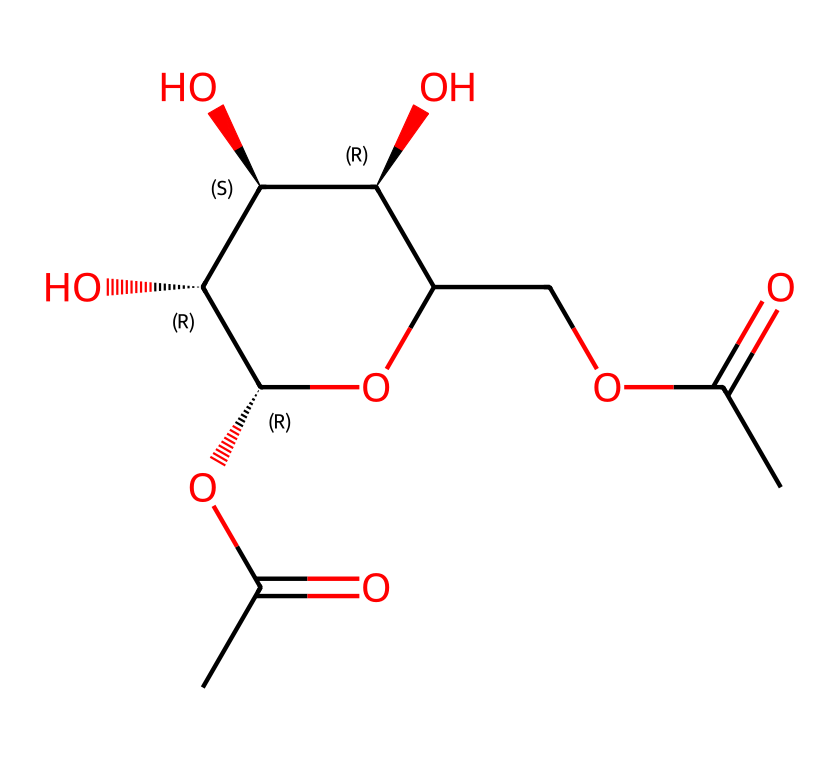What type of macromolecule is represented by this structure? The structure contains carbohydrates, characterized by carbon, hydrogen, and oxygen atoms in a specific ratio. It specifically shows features typical of polysaccharides like pectin.
Answer: carbohydrates How many carbon atoms are in this molecule? By analyzing the SMILES representation, we can count each 'C' in the structure. There are 7 carbon atoms present in the chain of the molecule.
Answer: 7 What functional group is evident in this structure? The molecule has carboxyl groups indicated by 'C(=O)O' appearing in the structure, which is characteristic of acids and indicates functional presence in sugars.
Answer: carboxyl What type of glycosidic linkage is present? The structure shows ether linkages between monomer units (O within the rings), common in polysaccharides where sugars are connected via glycosidic bonds.
Answer: ether What is a primary role of pectin in fruit jams? In fruit jams, pectin functions primarily as a gelling agent, helping to provide structure and consistency to the product when cooked with sugars and acids.
Answer: gelling agent How many hydroxyl (-OH) groups are present in the structure? By examining the structure, we identify several -OH (hydroxyl) groups connected to the carbon atoms. The molecule shows three hydroxyl groups attached to the carbon backbone.
Answer: 3 What is the configuration of the stereocenters in this molecule? The structure includes stereocenters indicated by '@' in the SMILES notation. There are a total of four stereocenters, confirming its configuration as a chiral molecule.
Answer: 4 